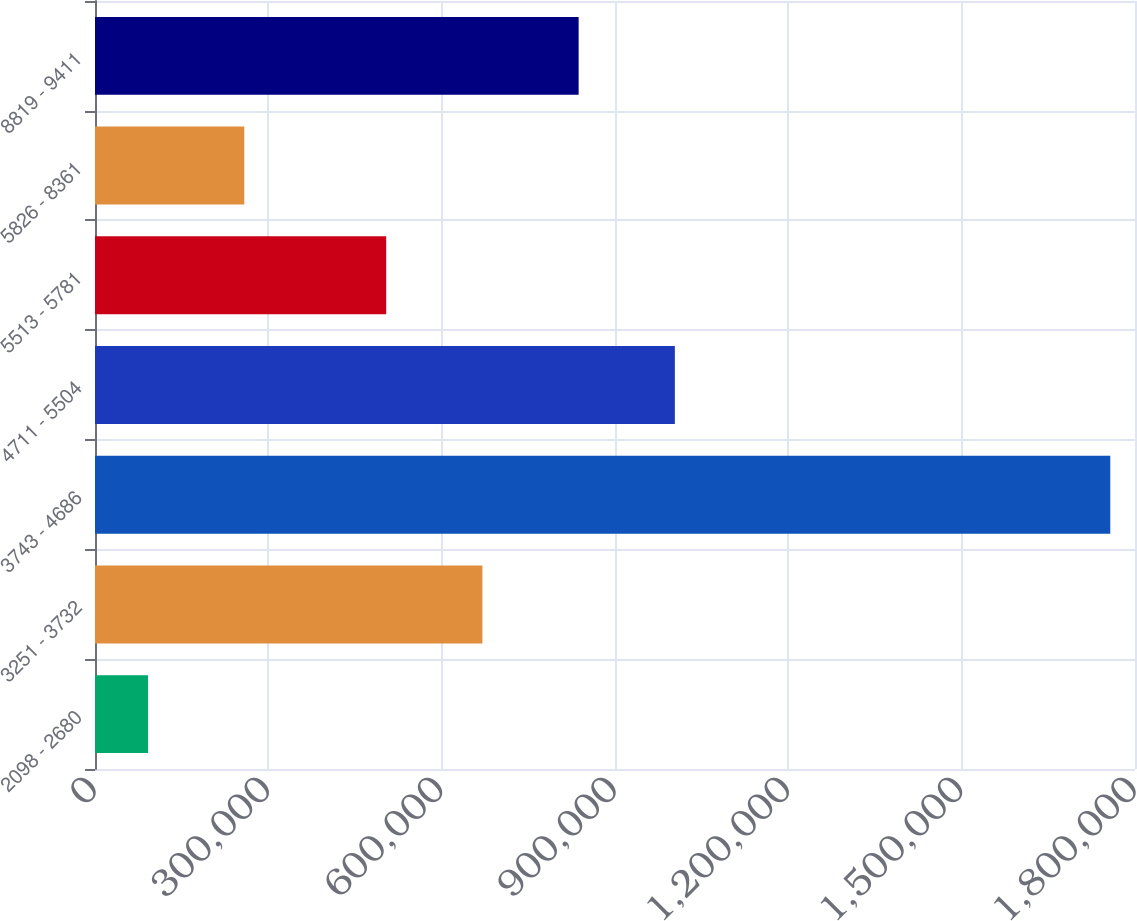Convert chart. <chart><loc_0><loc_0><loc_500><loc_500><bar_chart><fcel>2098 - 2680<fcel>3251 - 3732<fcel>3743 - 4686<fcel>4711 - 5504<fcel>5513 - 5781<fcel>5826 - 8361<fcel>8819 - 9411<nl><fcel>91800<fcel>670516<fcel>1.75721e+06<fcel>1.0036e+06<fcel>503975<fcel>258341<fcel>837058<nl></chart> 